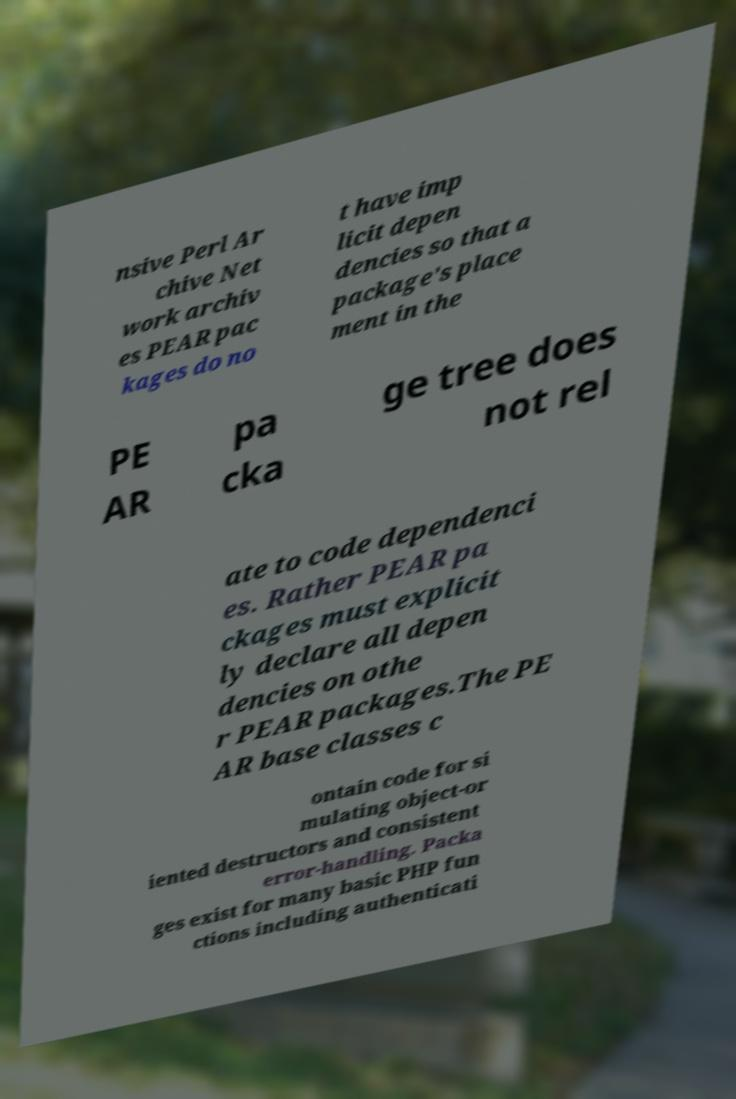Please read and relay the text visible in this image. What does it say? nsive Perl Ar chive Net work archiv es PEAR pac kages do no t have imp licit depen dencies so that a package's place ment in the PE AR pa cka ge tree does not rel ate to code dependenci es. Rather PEAR pa ckages must explicit ly declare all depen dencies on othe r PEAR packages.The PE AR base classes c ontain code for si mulating object-or iented destructors and consistent error-handling. Packa ges exist for many basic PHP fun ctions including authenticati 